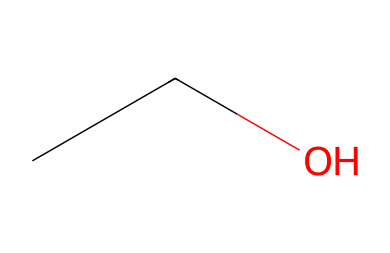What is the molecular formula of this compound? The SMILES representation "CCO" indicates that the compound consists of carbon (C) and oxygen (O) atoms. There are two carbon atoms, six hydrogen atoms (which are implied based on the connectivity), and one oxygen atom. Therefore, the molecular formula is C2H6O.
Answer: C2H6O How many carbon atoms are in the structure? The SMILES notation "CCO" clearly shows two 'C' symbols, indicating there are two carbon atoms in this molecule.
Answer: 2 What type of compound is this? Ethanol, represented by the SMILES "CCO", is an alcohol due to the presence of a hydroxyl group (-OH) that is indicated by the oxygen atom connected to a carbon.
Answer: alcohol How many hydrogen atoms are present in the molecule? The molecule's SMILES "CCO" indicates two carbon atoms and one oxygen atom, leading to the conclusion that there are six hydrogen atoms present in total, derived from the saturation of the carbon atoms.
Answer: 6 What is the effect of ethanol on neural signaling? Ethanol is a depressant that modifies neural signaling primarily by enhancing the effect of the neurotransmitter gamma-aminobutyric acid (GABA), which inhibits brain activity. This is evident in its ability to reduce neuronal excitability and alter synaptic communication.
Answer: depressant Is ethanol polar or nonpolar? The -OH group in ethanol (as indicated by the oxygen connected to the carbon atoms) contributes to its polarity, making ethanol a polar molecule, which affects its solubility in water and interactions with other polar substances.
Answer: polar 